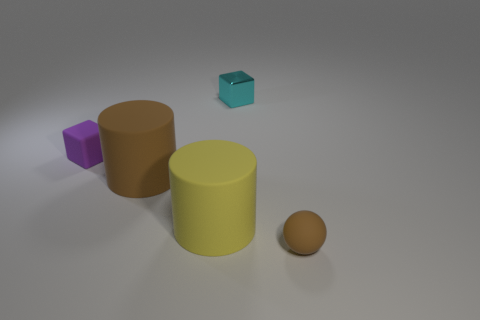Add 1 large objects. How many objects exist? 6 Subtract all balls. How many objects are left? 4 Add 4 purple matte objects. How many purple matte objects are left? 5 Add 5 tiny gray things. How many tiny gray things exist? 5 Subtract 0 gray cylinders. How many objects are left? 5 Subtract all large brown rubber objects. Subtract all yellow metal cylinders. How many objects are left? 4 